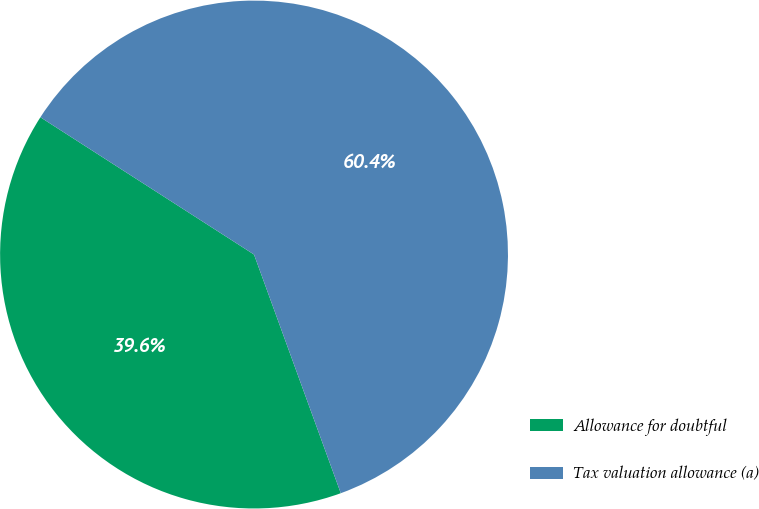<chart> <loc_0><loc_0><loc_500><loc_500><pie_chart><fcel>Allowance for doubtful<fcel>Tax valuation allowance (a)<nl><fcel>39.64%<fcel>60.36%<nl></chart> 